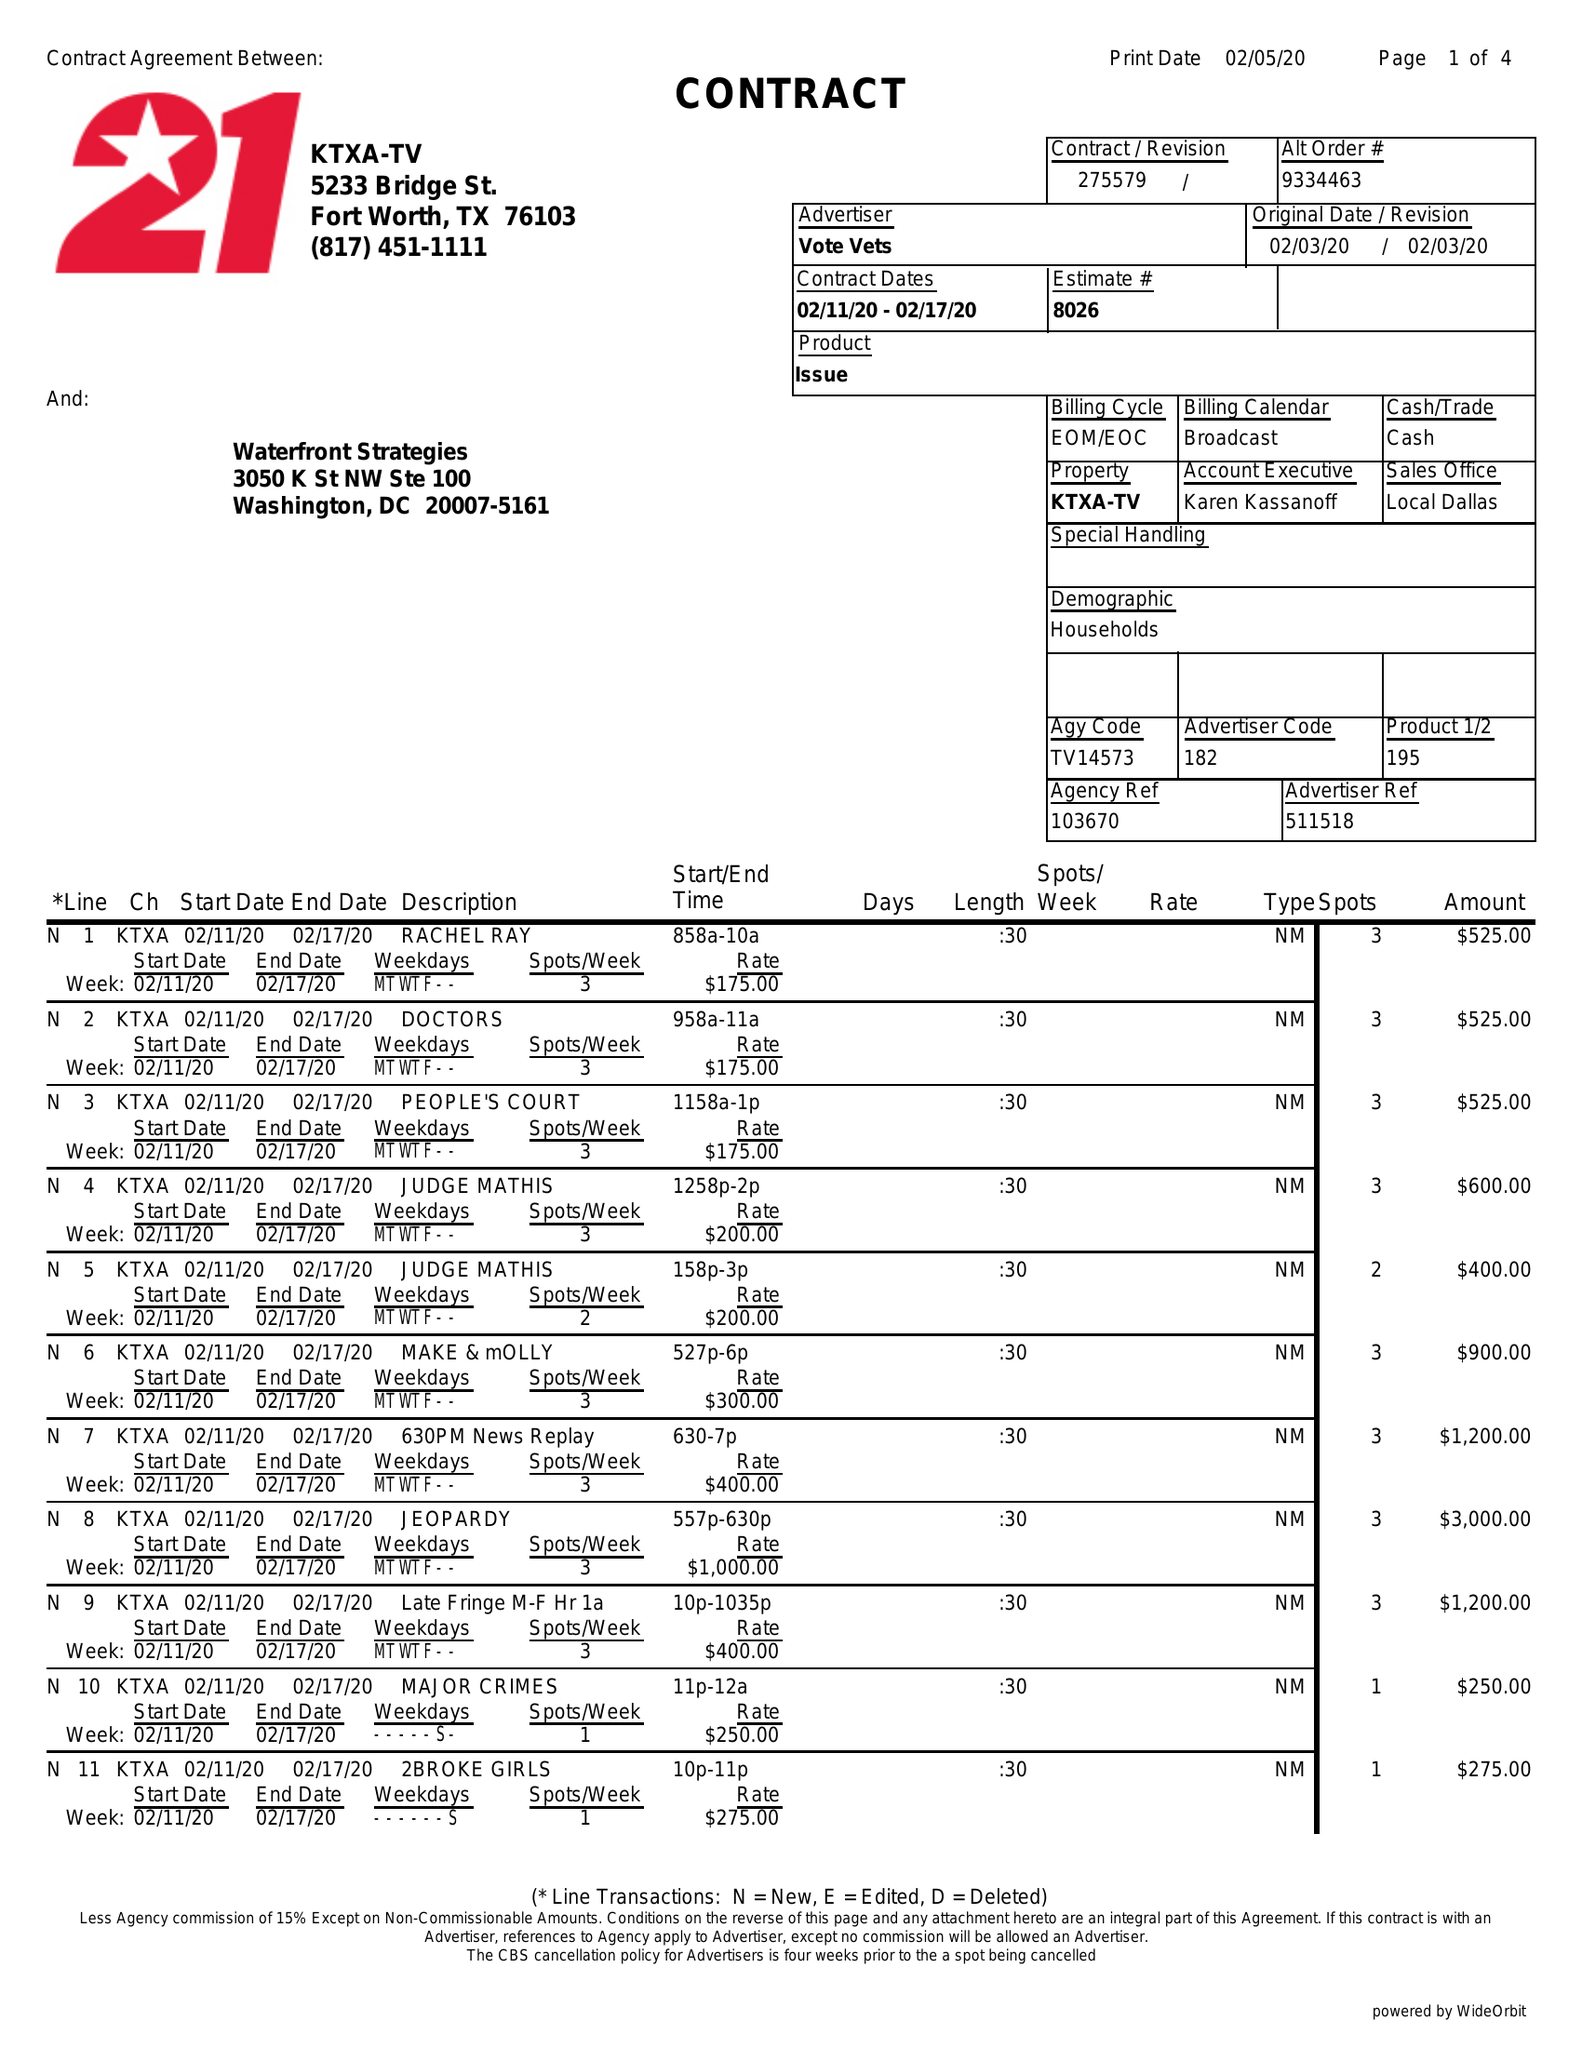What is the value for the flight_from?
Answer the question using a single word or phrase. 02/11/20 